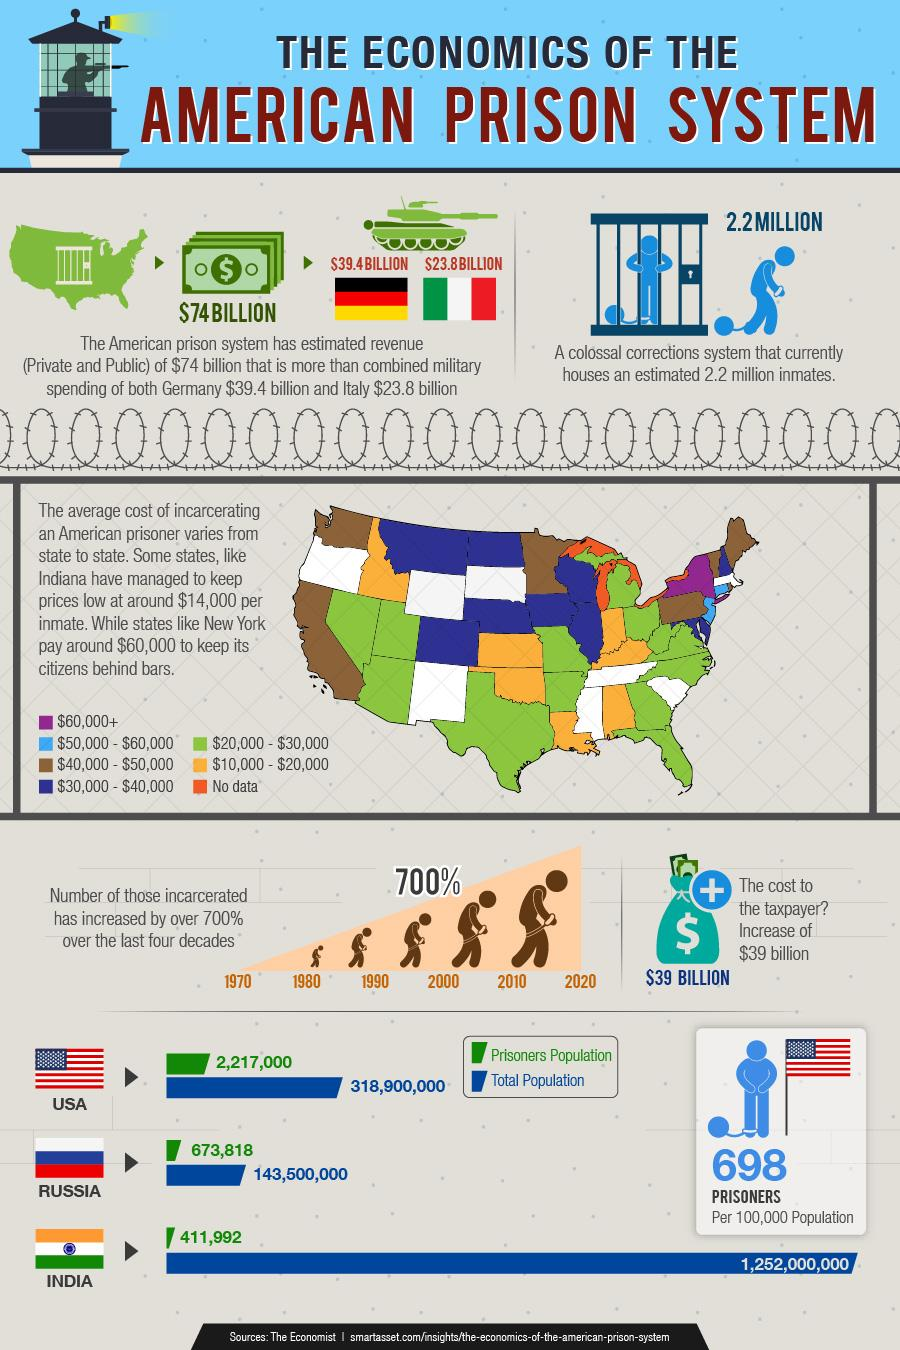Draw attention to some important aspects in this diagram. The military spending difference between Germany and Italy is approximately 15.6 billion dollars, with Germany spending more. According to the latest statistics, the average cost of incarcerating a prisoner in Indiana is approximately $14,000, while in New York, the cost is around $60,000. As of today, the total population of the United States of America is approximately 318,900,000 people. The infographic provides a comparison between the total population and the prisoner population of several countries, including the United States, Russia, and India. The military spending of several countries, including Italy and Germany, is presented in this infographic. 